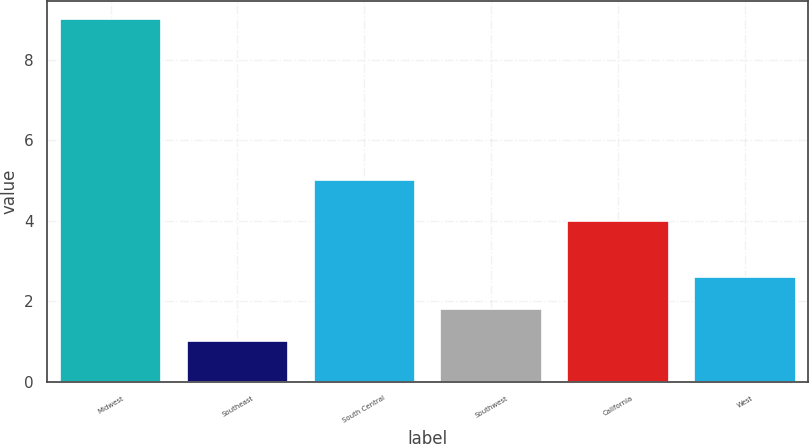Convert chart to OTSL. <chart><loc_0><loc_0><loc_500><loc_500><bar_chart><fcel>Midwest<fcel>Southeast<fcel>South Central<fcel>Southwest<fcel>California<fcel>West<nl><fcel>9<fcel>1<fcel>5<fcel>1.8<fcel>4<fcel>2.6<nl></chart> 